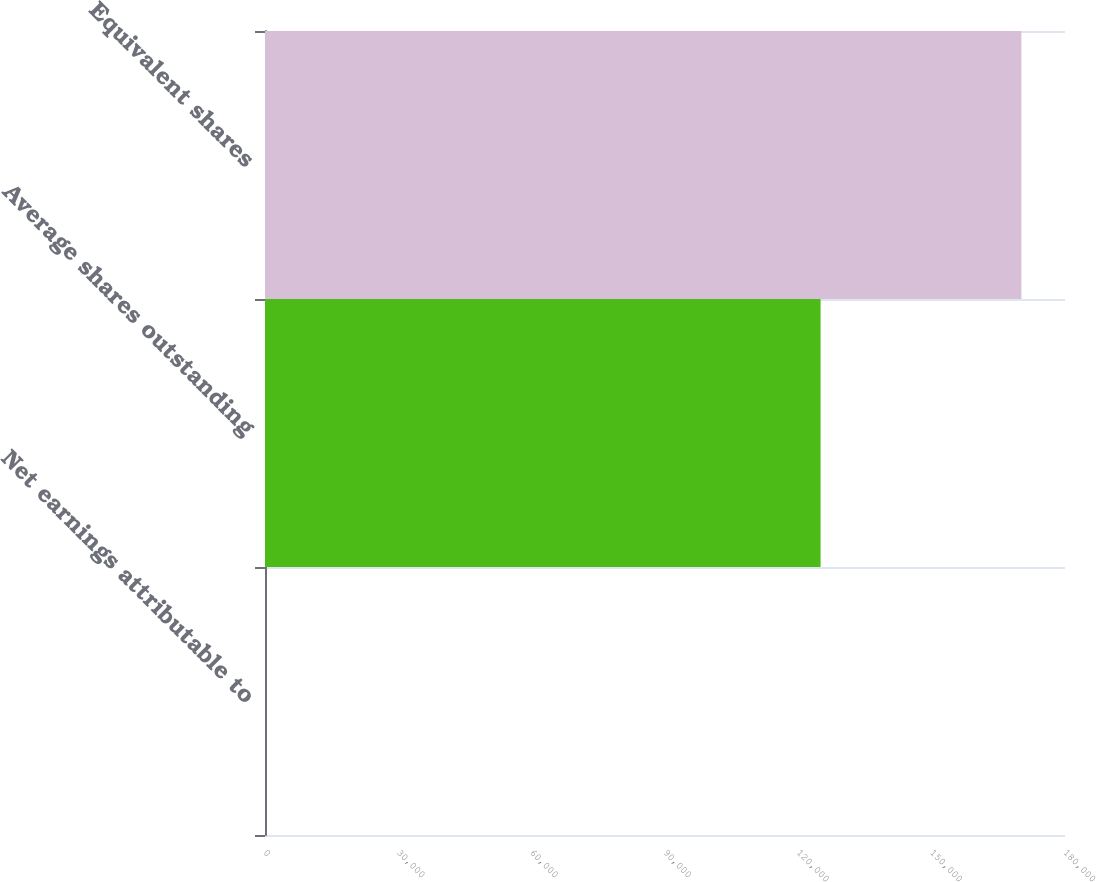<chart> <loc_0><loc_0><loc_500><loc_500><bar_chart><fcel>Net earnings attributable to<fcel>Average shares outstanding<fcel>Equivalent shares<nl><fcel>3.57<fcel>125006<fcel>170189<nl></chart> 